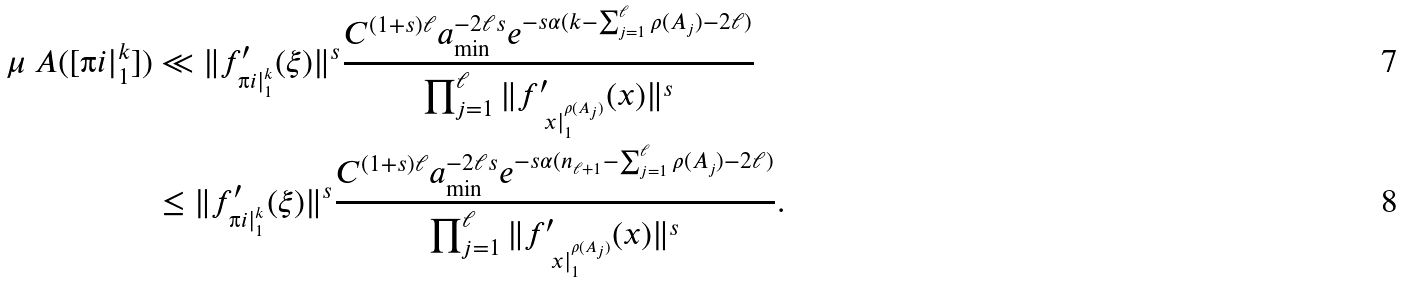<formula> <loc_0><loc_0><loc_500><loc_500>\mu _ { \ } A ( [ \i i | _ { 1 } ^ { k } ] ) & \ll \| f _ { \i i | _ { 1 } ^ { k } } ^ { \prime } ( \xi ) \| ^ { s } \frac { C ^ { ( 1 + s ) \ell } a _ { \min } ^ { - 2 \ell s } e ^ { - s \alpha ( k - \sum _ { j = 1 } ^ { \ell } \rho ( A _ { j } ) - 2 \ell ) } } { \prod _ { j = 1 } ^ { \ell } \| f _ { \ x | _ { 1 } ^ { \rho ( A _ { j } ) } } ^ { \prime } ( x ) \| ^ { s } } \\ & \leq \| f _ { \i i | _ { 1 } ^ { k } } ^ { \prime } ( \xi ) \| ^ { s } \frac { C ^ { ( 1 + s ) \ell } a _ { \min } ^ { - 2 \ell s } e ^ { - s \alpha ( n _ { \ell + 1 } - \sum _ { j = 1 } ^ { \ell } \rho ( A _ { j } ) - 2 \ell ) } } { \prod _ { j = 1 } ^ { \ell } \| f _ { \ x | _ { 1 } ^ { \rho ( A _ { j } ) } } ^ { \prime } ( x ) \| ^ { s } } .</formula> 